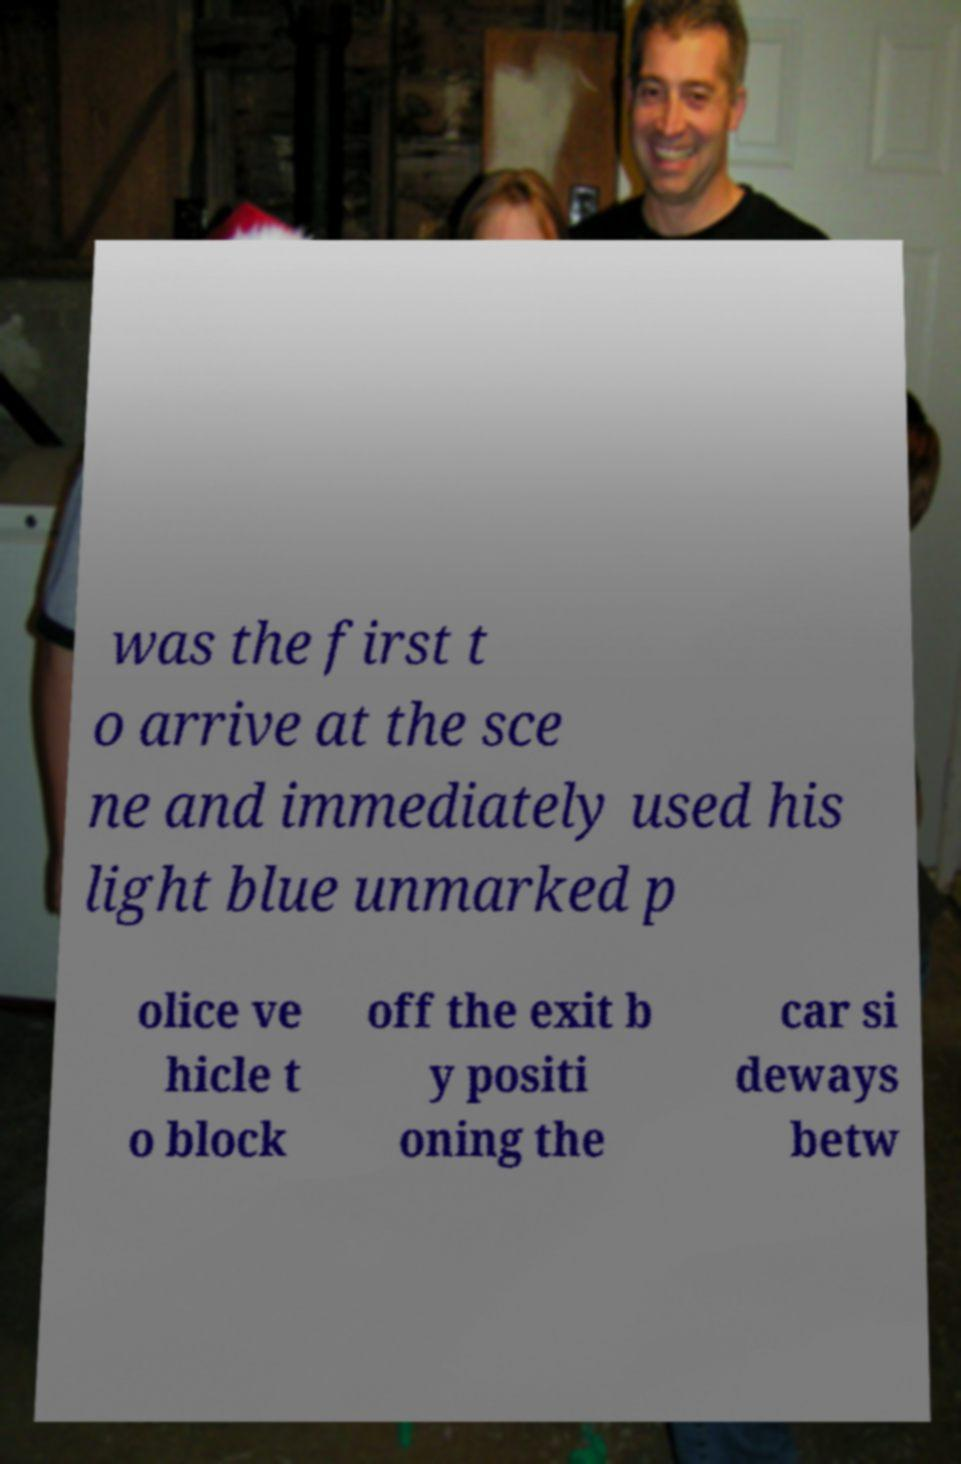Can you accurately transcribe the text from the provided image for me? was the first t o arrive at the sce ne and immediately used his light blue unmarked p olice ve hicle t o block off the exit b y positi oning the car si deways betw 